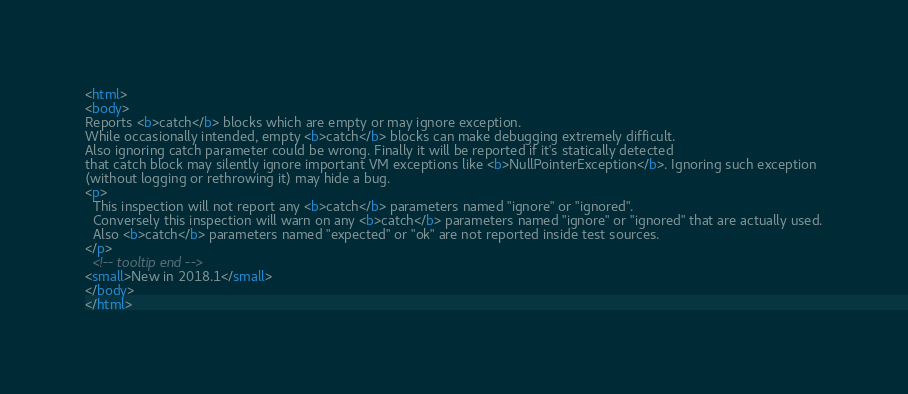Convert code to text. <code><loc_0><loc_0><loc_500><loc_500><_HTML_><html>
<body>
Reports <b>catch</b> blocks which are empty or may ignore exception.
While occasionally intended, empty <b>catch</b> blocks can make debugging extremely difficult.
Also ignoring catch parameter could be wrong. Finally it will be reported if it's statically detected
that catch block may silently ignore important VM exceptions like <b>NullPointerException</b>. Ignoring such exception
(without logging or rethrowing it) may hide a bug.
<p>
  This inspection will not report any <b>catch</b> parameters named "ignore" or "ignored".
  Conversely this inspection will warn on any <b>catch</b> parameters named "ignore" or "ignored" that are actually used.
  Also <b>catch</b> parameters named "expected" or "ok" are not reported inside test sources.
</p>
  <!-- tooltip end -->
<small>New in 2018.1</small>
</body>
</html></code> 